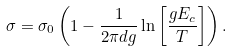Convert formula to latex. <formula><loc_0><loc_0><loc_500><loc_500>\sigma = \sigma _ { 0 } \left ( 1 - \frac { 1 } { 2 \pi d g } \ln \left [ \frac { g E _ { c } } { T } \right ] \right ) .</formula> 